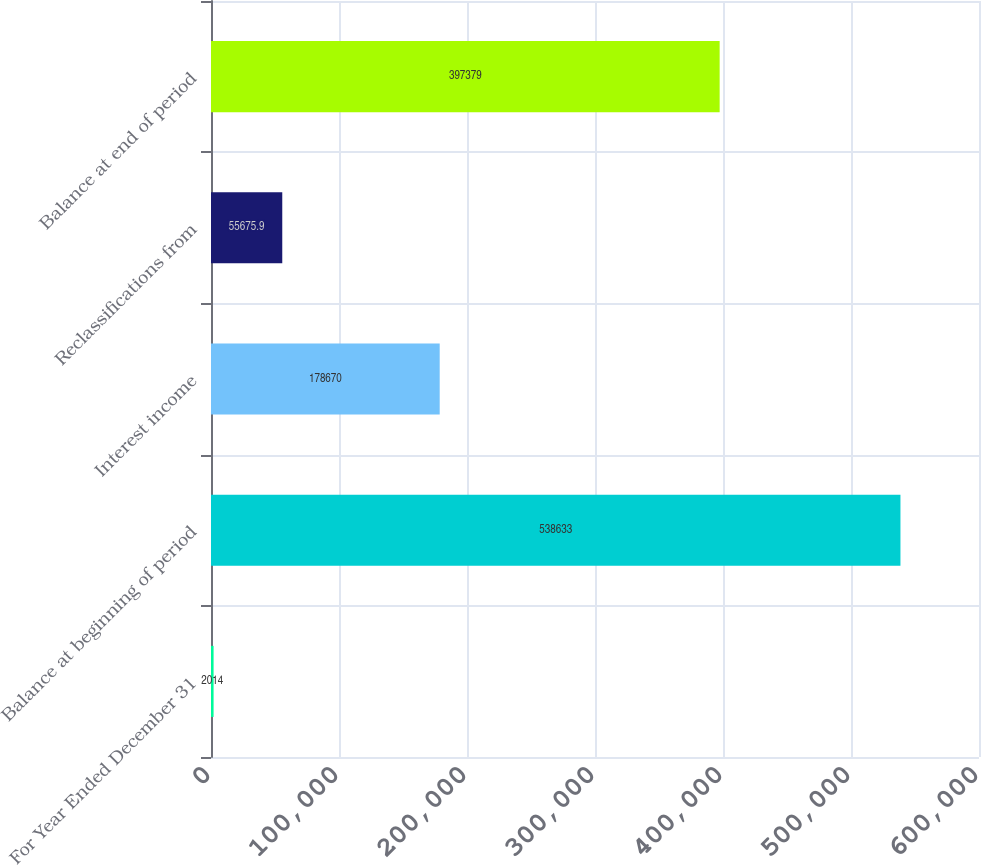Convert chart. <chart><loc_0><loc_0><loc_500><loc_500><bar_chart><fcel>For Year Ended December 31<fcel>Balance at beginning of period<fcel>Interest income<fcel>Reclassifications from<fcel>Balance at end of period<nl><fcel>2014<fcel>538633<fcel>178670<fcel>55675.9<fcel>397379<nl></chart> 